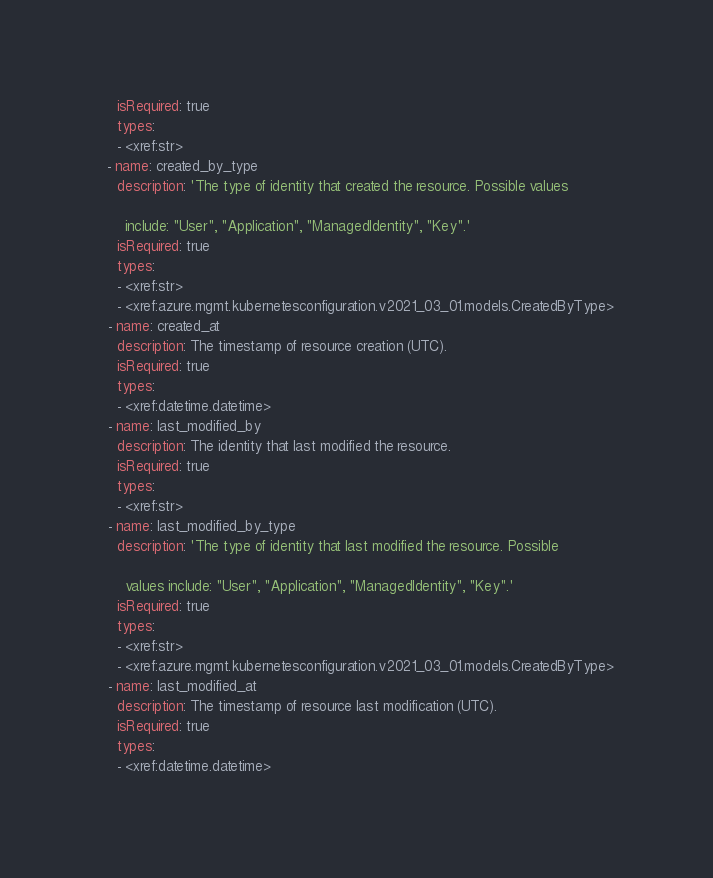<code> <loc_0><loc_0><loc_500><loc_500><_YAML_>    isRequired: true
    types:
    - <xref:str>
  - name: created_by_type
    description: 'The type of identity that created the resource. Possible values

      include: "User", "Application", "ManagedIdentity", "Key".'
    isRequired: true
    types:
    - <xref:str>
    - <xref:azure.mgmt.kubernetesconfiguration.v2021_03_01.models.CreatedByType>
  - name: created_at
    description: The timestamp of resource creation (UTC).
    isRequired: true
    types:
    - <xref:datetime.datetime>
  - name: last_modified_by
    description: The identity that last modified the resource.
    isRequired: true
    types:
    - <xref:str>
  - name: last_modified_by_type
    description: 'The type of identity that last modified the resource. Possible

      values include: "User", "Application", "ManagedIdentity", "Key".'
    isRequired: true
    types:
    - <xref:str>
    - <xref:azure.mgmt.kubernetesconfiguration.v2021_03_01.models.CreatedByType>
  - name: last_modified_at
    description: The timestamp of resource last modification (UTC).
    isRequired: true
    types:
    - <xref:datetime.datetime>
</code> 